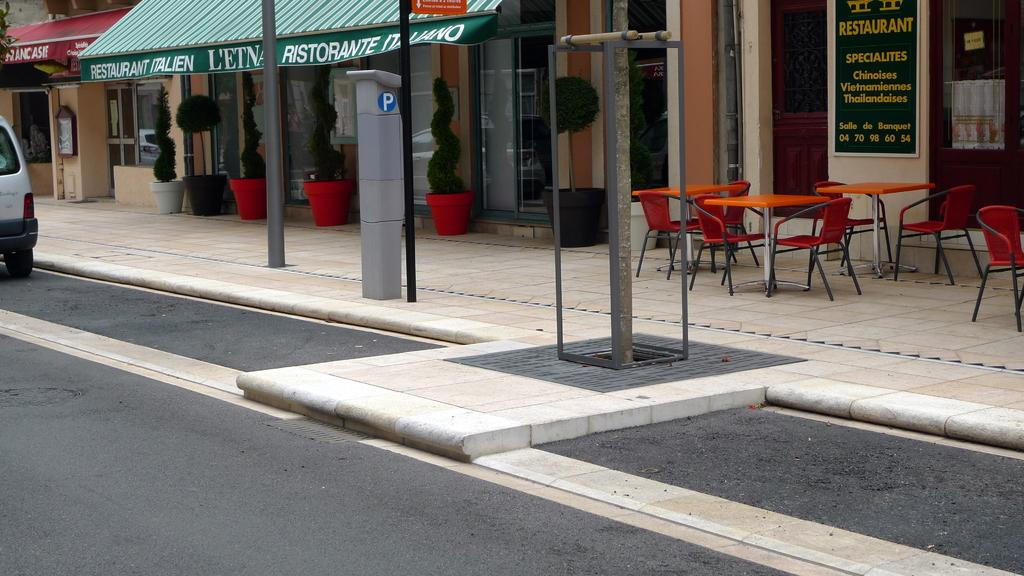What is on the road in the image? There is a vehicle on the road in the image. What structures can be seen in the image? There are poles, chairs, tables, boards, and stalls in the image. What theory is being discussed at the stalls in the image? There is no indication of a discussion or a theory being presented in the image; it simply shows stalls and other structures. 